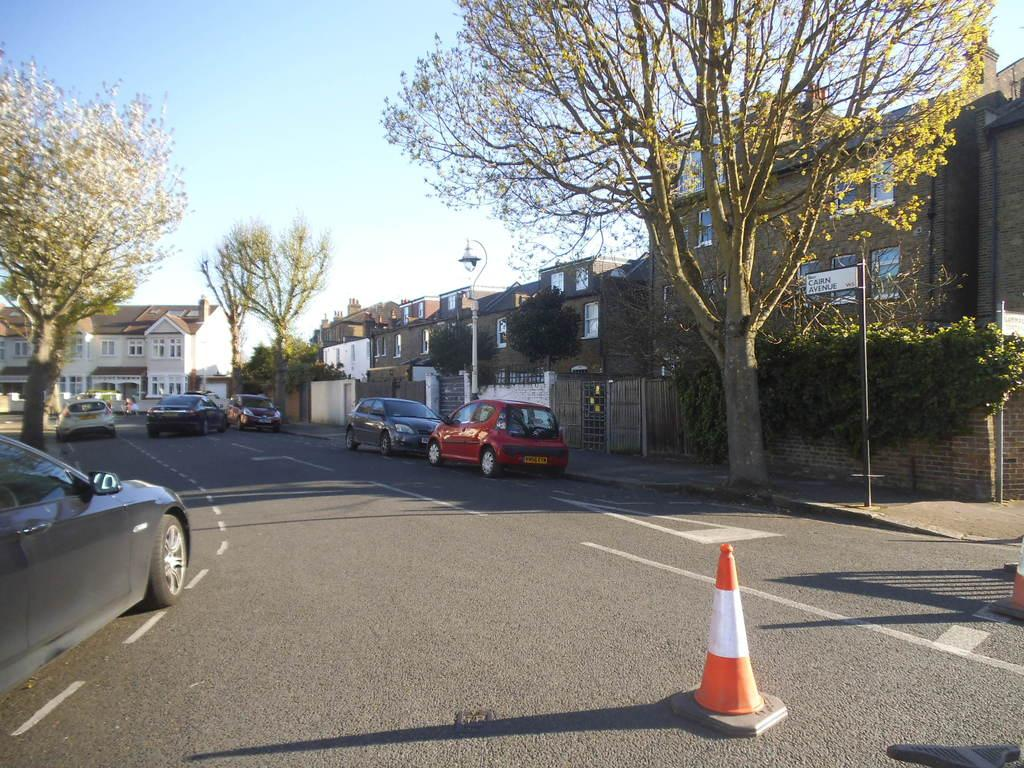What can be seen in the image related to transportation? There are vehicles in the image. What separates the lanes of traffic in the image? There is a road divider in the image. What are the road divider blocks made of? The road divider blocks are on the road in the image. What type of vegetation is visible beside the road? There are trees beside the road in the image. What type of structures are visible beside the road? There are buildings beside the road in the image. What type of poles are visible beside the road? There are poles beside the road in the image. What type of beef is being served at the restaurant in the image? There is no restaurant or beef present in the image. Can you show me the map of the area in the image? There is no map present in the image. 